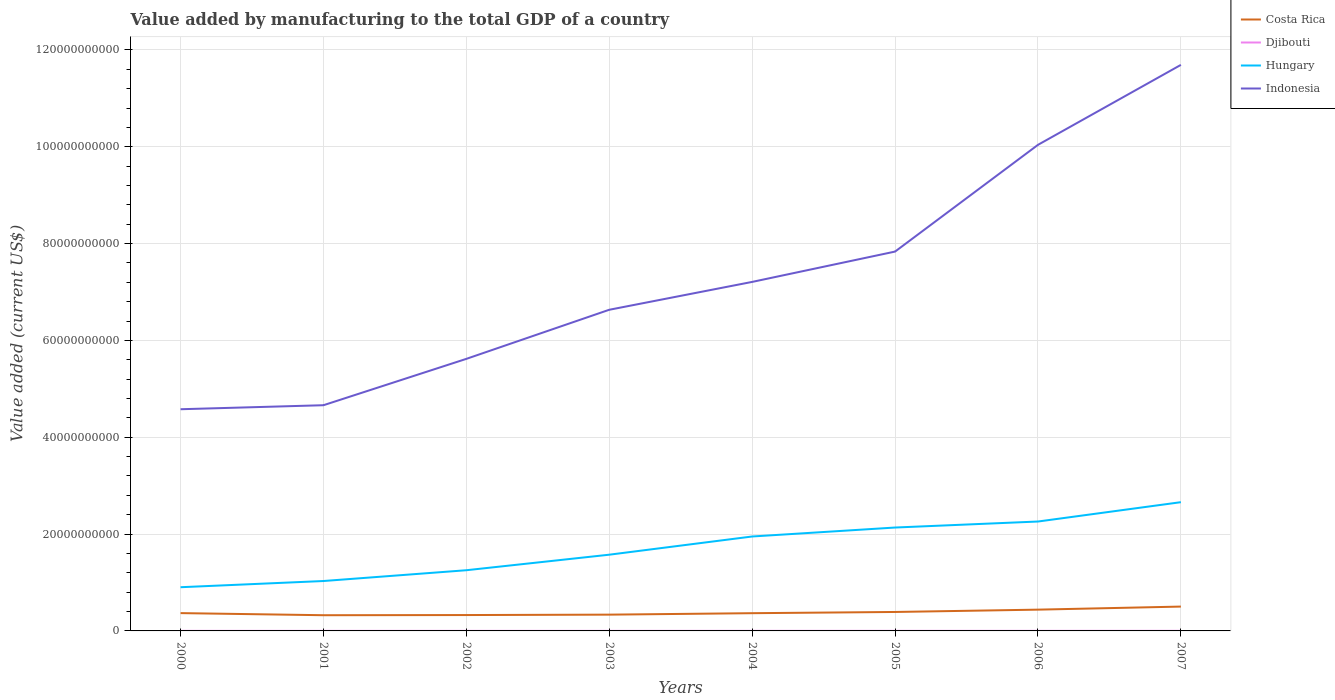Across all years, what is the maximum value added by manufacturing to the total GDP in Hungary?
Provide a succinct answer. 9.03e+09. In which year was the value added by manufacturing to the total GDP in Hungary maximum?
Provide a succinct answer. 2000. What is the total value added by manufacturing to the total GDP in Costa Rica in the graph?
Your answer should be very brief. -4.81e+08. What is the difference between the highest and the second highest value added by manufacturing to the total GDP in Djibouti?
Ensure brevity in your answer.  5.74e+06. What is the difference between the highest and the lowest value added by manufacturing to the total GDP in Hungary?
Offer a terse response. 4. Are the values on the major ticks of Y-axis written in scientific E-notation?
Ensure brevity in your answer.  No. How many legend labels are there?
Give a very brief answer. 4. What is the title of the graph?
Ensure brevity in your answer.  Value added by manufacturing to the total GDP of a country. Does "Botswana" appear as one of the legend labels in the graph?
Your answer should be very brief. No. What is the label or title of the X-axis?
Give a very brief answer. Years. What is the label or title of the Y-axis?
Keep it short and to the point. Value added (current US$). What is the Value added (current US$) of Costa Rica in 2000?
Provide a succinct answer. 3.68e+09. What is the Value added (current US$) of Djibouti in 2000?
Give a very brief answer. 1.26e+07. What is the Value added (current US$) in Hungary in 2000?
Offer a terse response. 9.03e+09. What is the Value added (current US$) of Indonesia in 2000?
Provide a short and direct response. 4.58e+1. What is the Value added (current US$) of Costa Rica in 2001?
Provide a short and direct response. 3.24e+09. What is the Value added (current US$) in Djibouti in 2001?
Offer a very short reply. 1.32e+07. What is the Value added (current US$) in Hungary in 2001?
Your answer should be compact. 1.03e+1. What is the Value added (current US$) in Indonesia in 2001?
Provide a succinct answer. 4.66e+1. What is the Value added (current US$) of Costa Rica in 2002?
Offer a very short reply. 3.28e+09. What is the Value added (current US$) in Djibouti in 2002?
Your answer should be compact. 1.37e+07. What is the Value added (current US$) in Hungary in 2002?
Provide a succinct answer. 1.25e+1. What is the Value added (current US$) of Indonesia in 2002?
Provide a succinct answer. 5.62e+1. What is the Value added (current US$) of Costa Rica in 2003?
Ensure brevity in your answer.  3.36e+09. What is the Value added (current US$) in Djibouti in 2003?
Keep it short and to the point. 1.44e+07. What is the Value added (current US$) of Hungary in 2003?
Offer a terse response. 1.57e+1. What is the Value added (current US$) in Indonesia in 2003?
Make the answer very short. 6.63e+1. What is the Value added (current US$) of Costa Rica in 2004?
Your answer should be very brief. 3.66e+09. What is the Value added (current US$) in Djibouti in 2004?
Offer a terse response. 1.54e+07. What is the Value added (current US$) of Hungary in 2004?
Offer a very short reply. 1.95e+1. What is the Value added (current US$) of Indonesia in 2004?
Offer a very short reply. 7.21e+1. What is the Value added (current US$) of Costa Rica in 2005?
Offer a terse response. 3.91e+09. What is the Value added (current US$) of Djibouti in 2005?
Provide a succinct answer. 1.63e+07. What is the Value added (current US$) of Hungary in 2005?
Make the answer very short. 2.14e+1. What is the Value added (current US$) of Indonesia in 2005?
Keep it short and to the point. 7.83e+1. What is the Value added (current US$) in Costa Rica in 2006?
Provide a succinct answer. 4.40e+09. What is the Value added (current US$) of Djibouti in 2006?
Give a very brief answer. 1.73e+07. What is the Value added (current US$) in Hungary in 2006?
Provide a succinct answer. 2.26e+1. What is the Value added (current US$) of Indonesia in 2006?
Keep it short and to the point. 1.00e+11. What is the Value added (current US$) of Costa Rica in 2007?
Keep it short and to the point. 5.03e+09. What is the Value added (current US$) of Djibouti in 2007?
Your answer should be compact. 1.83e+07. What is the Value added (current US$) of Hungary in 2007?
Provide a succinct answer. 2.66e+1. What is the Value added (current US$) in Indonesia in 2007?
Provide a short and direct response. 1.17e+11. Across all years, what is the maximum Value added (current US$) in Costa Rica?
Offer a terse response. 5.03e+09. Across all years, what is the maximum Value added (current US$) in Djibouti?
Keep it short and to the point. 1.83e+07. Across all years, what is the maximum Value added (current US$) of Hungary?
Your answer should be compact. 2.66e+1. Across all years, what is the maximum Value added (current US$) of Indonesia?
Provide a succinct answer. 1.17e+11. Across all years, what is the minimum Value added (current US$) in Costa Rica?
Your answer should be compact. 3.24e+09. Across all years, what is the minimum Value added (current US$) in Djibouti?
Offer a very short reply. 1.26e+07. Across all years, what is the minimum Value added (current US$) of Hungary?
Make the answer very short. 9.03e+09. Across all years, what is the minimum Value added (current US$) of Indonesia?
Give a very brief answer. 4.58e+1. What is the total Value added (current US$) in Costa Rica in the graph?
Keep it short and to the point. 3.06e+1. What is the total Value added (current US$) of Djibouti in the graph?
Provide a succinct answer. 1.21e+08. What is the total Value added (current US$) in Hungary in the graph?
Keep it short and to the point. 1.38e+11. What is the total Value added (current US$) in Indonesia in the graph?
Keep it short and to the point. 5.83e+11. What is the difference between the Value added (current US$) of Costa Rica in 2000 and that in 2001?
Make the answer very short. 4.34e+08. What is the difference between the Value added (current US$) in Djibouti in 2000 and that in 2001?
Provide a succinct answer. -6.18e+05. What is the difference between the Value added (current US$) in Hungary in 2000 and that in 2001?
Your response must be concise. -1.28e+09. What is the difference between the Value added (current US$) of Indonesia in 2000 and that in 2001?
Make the answer very short. -8.29e+08. What is the difference between the Value added (current US$) of Costa Rica in 2000 and that in 2002?
Your answer should be compact. 4.00e+08. What is the difference between the Value added (current US$) in Djibouti in 2000 and that in 2002?
Offer a terse response. -1.11e+06. What is the difference between the Value added (current US$) of Hungary in 2000 and that in 2002?
Ensure brevity in your answer.  -3.51e+09. What is the difference between the Value added (current US$) of Indonesia in 2000 and that in 2002?
Make the answer very short. -1.04e+1. What is the difference between the Value added (current US$) of Costa Rica in 2000 and that in 2003?
Offer a very short reply. 3.16e+08. What is the difference between the Value added (current US$) of Djibouti in 2000 and that in 2003?
Give a very brief answer. -1.81e+06. What is the difference between the Value added (current US$) of Hungary in 2000 and that in 2003?
Give a very brief answer. -6.72e+09. What is the difference between the Value added (current US$) in Indonesia in 2000 and that in 2003?
Ensure brevity in your answer.  -2.05e+1. What is the difference between the Value added (current US$) of Costa Rica in 2000 and that in 2004?
Provide a short and direct response. 1.61e+07. What is the difference between the Value added (current US$) of Djibouti in 2000 and that in 2004?
Your answer should be very brief. -2.86e+06. What is the difference between the Value added (current US$) of Hungary in 2000 and that in 2004?
Offer a terse response. -1.05e+1. What is the difference between the Value added (current US$) of Indonesia in 2000 and that in 2004?
Provide a short and direct response. -2.63e+1. What is the difference between the Value added (current US$) in Costa Rica in 2000 and that in 2005?
Make the answer very short. -2.38e+08. What is the difference between the Value added (current US$) in Djibouti in 2000 and that in 2005?
Offer a terse response. -3.74e+06. What is the difference between the Value added (current US$) of Hungary in 2000 and that in 2005?
Offer a terse response. -1.23e+1. What is the difference between the Value added (current US$) of Indonesia in 2000 and that in 2005?
Offer a terse response. -3.26e+1. What is the difference between the Value added (current US$) of Costa Rica in 2000 and that in 2006?
Provide a short and direct response. -7.19e+08. What is the difference between the Value added (current US$) in Djibouti in 2000 and that in 2006?
Provide a short and direct response. -4.69e+06. What is the difference between the Value added (current US$) of Hungary in 2000 and that in 2006?
Provide a short and direct response. -1.36e+1. What is the difference between the Value added (current US$) of Indonesia in 2000 and that in 2006?
Ensure brevity in your answer.  -5.46e+1. What is the difference between the Value added (current US$) in Costa Rica in 2000 and that in 2007?
Keep it short and to the point. -1.35e+09. What is the difference between the Value added (current US$) of Djibouti in 2000 and that in 2007?
Offer a very short reply. -5.74e+06. What is the difference between the Value added (current US$) of Hungary in 2000 and that in 2007?
Offer a terse response. -1.76e+1. What is the difference between the Value added (current US$) in Indonesia in 2000 and that in 2007?
Ensure brevity in your answer.  -7.11e+1. What is the difference between the Value added (current US$) of Costa Rica in 2001 and that in 2002?
Your answer should be very brief. -3.42e+07. What is the difference between the Value added (current US$) in Djibouti in 2001 and that in 2002?
Provide a succinct answer. -4.95e+05. What is the difference between the Value added (current US$) of Hungary in 2001 and that in 2002?
Give a very brief answer. -2.23e+09. What is the difference between the Value added (current US$) in Indonesia in 2001 and that in 2002?
Offer a very short reply. -9.58e+09. What is the difference between the Value added (current US$) of Costa Rica in 2001 and that in 2003?
Your answer should be compact. -1.18e+08. What is the difference between the Value added (current US$) of Djibouti in 2001 and that in 2003?
Provide a short and direct response. -1.20e+06. What is the difference between the Value added (current US$) of Hungary in 2001 and that in 2003?
Your response must be concise. -5.44e+09. What is the difference between the Value added (current US$) of Indonesia in 2001 and that in 2003?
Provide a succinct answer. -1.97e+1. What is the difference between the Value added (current US$) in Costa Rica in 2001 and that in 2004?
Keep it short and to the point. -4.18e+08. What is the difference between the Value added (current US$) of Djibouti in 2001 and that in 2004?
Provide a short and direct response. -2.24e+06. What is the difference between the Value added (current US$) in Hungary in 2001 and that in 2004?
Give a very brief answer. -9.20e+09. What is the difference between the Value added (current US$) of Indonesia in 2001 and that in 2004?
Provide a succinct answer. -2.55e+1. What is the difference between the Value added (current US$) in Costa Rica in 2001 and that in 2005?
Your answer should be compact. -6.72e+08. What is the difference between the Value added (current US$) of Djibouti in 2001 and that in 2005?
Provide a succinct answer. -3.12e+06. What is the difference between the Value added (current US$) of Hungary in 2001 and that in 2005?
Your answer should be very brief. -1.10e+1. What is the difference between the Value added (current US$) in Indonesia in 2001 and that in 2005?
Offer a very short reply. -3.17e+1. What is the difference between the Value added (current US$) in Costa Rica in 2001 and that in 2006?
Your response must be concise. -1.15e+09. What is the difference between the Value added (current US$) of Djibouti in 2001 and that in 2006?
Your answer should be very brief. -4.07e+06. What is the difference between the Value added (current US$) of Hungary in 2001 and that in 2006?
Your response must be concise. -1.23e+1. What is the difference between the Value added (current US$) of Indonesia in 2001 and that in 2006?
Provide a short and direct response. -5.38e+1. What is the difference between the Value added (current US$) in Costa Rica in 2001 and that in 2007?
Your answer should be very brief. -1.78e+09. What is the difference between the Value added (current US$) of Djibouti in 2001 and that in 2007?
Your answer should be very brief. -5.12e+06. What is the difference between the Value added (current US$) in Hungary in 2001 and that in 2007?
Offer a very short reply. -1.63e+1. What is the difference between the Value added (current US$) of Indonesia in 2001 and that in 2007?
Your answer should be compact. -7.03e+1. What is the difference between the Value added (current US$) of Costa Rica in 2002 and that in 2003?
Your answer should be compact. -8.42e+07. What is the difference between the Value added (current US$) of Djibouti in 2002 and that in 2003?
Provide a short and direct response. -7.02e+05. What is the difference between the Value added (current US$) of Hungary in 2002 and that in 2003?
Keep it short and to the point. -3.21e+09. What is the difference between the Value added (current US$) in Indonesia in 2002 and that in 2003?
Provide a short and direct response. -1.01e+1. What is the difference between the Value added (current US$) in Costa Rica in 2002 and that in 2004?
Provide a succinct answer. -3.84e+08. What is the difference between the Value added (current US$) in Djibouti in 2002 and that in 2004?
Your answer should be very brief. -1.75e+06. What is the difference between the Value added (current US$) in Hungary in 2002 and that in 2004?
Provide a succinct answer. -6.97e+09. What is the difference between the Value added (current US$) in Indonesia in 2002 and that in 2004?
Make the answer very short. -1.59e+1. What is the difference between the Value added (current US$) of Costa Rica in 2002 and that in 2005?
Offer a terse response. -6.38e+08. What is the difference between the Value added (current US$) of Djibouti in 2002 and that in 2005?
Keep it short and to the point. -2.62e+06. What is the difference between the Value added (current US$) of Hungary in 2002 and that in 2005?
Provide a succinct answer. -8.82e+09. What is the difference between the Value added (current US$) in Indonesia in 2002 and that in 2005?
Your answer should be compact. -2.22e+1. What is the difference between the Value added (current US$) in Costa Rica in 2002 and that in 2006?
Ensure brevity in your answer.  -1.12e+09. What is the difference between the Value added (current US$) in Djibouti in 2002 and that in 2006?
Offer a terse response. -3.58e+06. What is the difference between the Value added (current US$) in Hungary in 2002 and that in 2006?
Your answer should be very brief. -1.01e+1. What is the difference between the Value added (current US$) of Indonesia in 2002 and that in 2006?
Your answer should be very brief. -4.42e+1. What is the difference between the Value added (current US$) in Costa Rica in 2002 and that in 2007?
Your answer should be compact. -1.75e+09. What is the difference between the Value added (current US$) in Djibouti in 2002 and that in 2007?
Keep it short and to the point. -4.63e+06. What is the difference between the Value added (current US$) of Hungary in 2002 and that in 2007?
Make the answer very short. -1.41e+1. What is the difference between the Value added (current US$) in Indonesia in 2002 and that in 2007?
Keep it short and to the point. -6.07e+1. What is the difference between the Value added (current US$) of Costa Rica in 2003 and that in 2004?
Your answer should be compact. -3.00e+08. What is the difference between the Value added (current US$) of Djibouti in 2003 and that in 2004?
Offer a very short reply. -1.04e+06. What is the difference between the Value added (current US$) of Hungary in 2003 and that in 2004?
Provide a succinct answer. -3.76e+09. What is the difference between the Value added (current US$) of Indonesia in 2003 and that in 2004?
Your answer should be very brief. -5.75e+09. What is the difference between the Value added (current US$) in Costa Rica in 2003 and that in 2005?
Provide a succinct answer. -5.53e+08. What is the difference between the Value added (current US$) of Djibouti in 2003 and that in 2005?
Your answer should be very brief. -1.92e+06. What is the difference between the Value added (current US$) in Hungary in 2003 and that in 2005?
Provide a succinct answer. -5.61e+09. What is the difference between the Value added (current US$) of Indonesia in 2003 and that in 2005?
Ensure brevity in your answer.  -1.20e+1. What is the difference between the Value added (current US$) in Costa Rica in 2003 and that in 2006?
Provide a succinct answer. -1.03e+09. What is the difference between the Value added (current US$) in Djibouti in 2003 and that in 2006?
Your answer should be compact. -2.87e+06. What is the difference between the Value added (current US$) of Hungary in 2003 and that in 2006?
Provide a short and direct response. -6.85e+09. What is the difference between the Value added (current US$) of Indonesia in 2003 and that in 2006?
Make the answer very short. -3.41e+1. What is the difference between the Value added (current US$) of Costa Rica in 2003 and that in 2007?
Provide a short and direct response. -1.67e+09. What is the difference between the Value added (current US$) of Djibouti in 2003 and that in 2007?
Offer a terse response. -3.93e+06. What is the difference between the Value added (current US$) of Hungary in 2003 and that in 2007?
Your response must be concise. -1.08e+1. What is the difference between the Value added (current US$) in Indonesia in 2003 and that in 2007?
Provide a succinct answer. -5.06e+1. What is the difference between the Value added (current US$) in Costa Rica in 2004 and that in 2005?
Provide a short and direct response. -2.54e+08. What is the difference between the Value added (current US$) of Djibouti in 2004 and that in 2005?
Offer a very short reply. -8.77e+05. What is the difference between the Value added (current US$) in Hungary in 2004 and that in 2005?
Offer a very short reply. -1.85e+09. What is the difference between the Value added (current US$) of Indonesia in 2004 and that in 2005?
Your answer should be very brief. -6.27e+09. What is the difference between the Value added (current US$) of Costa Rica in 2004 and that in 2006?
Give a very brief answer. -7.35e+08. What is the difference between the Value added (current US$) of Djibouti in 2004 and that in 2006?
Provide a short and direct response. -1.83e+06. What is the difference between the Value added (current US$) in Hungary in 2004 and that in 2006?
Offer a very short reply. -3.09e+09. What is the difference between the Value added (current US$) of Indonesia in 2004 and that in 2006?
Provide a succinct answer. -2.83e+1. What is the difference between the Value added (current US$) of Costa Rica in 2004 and that in 2007?
Your answer should be compact. -1.37e+09. What is the difference between the Value added (current US$) of Djibouti in 2004 and that in 2007?
Give a very brief answer. -2.88e+06. What is the difference between the Value added (current US$) in Hungary in 2004 and that in 2007?
Offer a terse response. -7.09e+09. What is the difference between the Value added (current US$) of Indonesia in 2004 and that in 2007?
Make the answer very short. -4.48e+1. What is the difference between the Value added (current US$) in Costa Rica in 2005 and that in 2006?
Make the answer very short. -4.81e+08. What is the difference between the Value added (current US$) of Djibouti in 2005 and that in 2006?
Your answer should be very brief. -9.53e+05. What is the difference between the Value added (current US$) in Hungary in 2005 and that in 2006?
Offer a very short reply. -1.24e+09. What is the difference between the Value added (current US$) in Indonesia in 2005 and that in 2006?
Make the answer very short. -2.20e+1. What is the difference between the Value added (current US$) in Costa Rica in 2005 and that in 2007?
Make the answer very short. -1.11e+09. What is the difference between the Value added (current US$) in Djibouti in 2005 and that in 2007?
Ensure brevity in your answer.  -2.00e+06. What is the difference between the Value added (current US$) in Hungary in 2005 and that in 2007?
Give a very brief answer. -5.24e+09. What is the difference between the Value added (current US$) in Indonesia in 2005 and that in 2007?
Make the answer very short. -3.86e+1. What is the difference between the Value added (current US$) of Costa Rica in 2006 and that in 2007?
Provide a succinct answer. -6.32e+08. What is the difference between the Value added (current US$) of Djibouti in 2006 and that in 2007?
Offer a terse response. -1.05e+06. What is the difference between the Value added (current US$) in Hungary in 2006 and that in 2007?
Offer a very short reply. -3.99e+09. What is the difference between the Value added (current US$) in Indonesia in 2006 and that in 2007?
Provide a short and direct response. -1.65e+1. What is the difference between the Value added (current US$) of Costa Rica in 2000 and the Value added (current US$) of Djibouti in 2001?
Offer a terse response. 3.66e+09. What is the difference between the Value added (current US$) in Costa Rica in 2000 and the Value added (current US$) in Hungary in 2001?
Offer a terse response. -6.63e+09. What is the difference between the Value added (current US$) of Costa Rica in 2000 and the Value added (current US$) of Indonesia in 2001?
Your answer should be very brief. -4.29e+1. What is the difference between the Value added (current US$) of Djibouti in 2000 and the Value added (current US$) of Hungary in 2001?
Your answer should be compact. -1.03e+1. What is the difference between the Value added (current US$) of Djibouti in 2000 and the Value added (current US$) of Indonesia in 2001?
Make the answer very short. -4.66e+1. What is the difference between the Value added (current US$) in Hungary in 2000 and the Value added (current US$) in Indonesia in 2001?
Give a very brief answer. -3.76e+1. What is the difference between the Value added (current US$) of Costa Rica in 2000 and the Value added (current US$) of Djibouti in 2002?
Offer a terse response. 3.66e+09. What is the difference between the Value added (current US$) in Costa Rica in 2000 and the Value added (current US$) in Hungary in 2002?
Give a very brief answer. -8.86e+09. What is the difference between the Value added (current US$) of Costa Rica in 2000 and the Value added (current US$) of Indonesia in 2002?
Your response must be concise. -5.25e+1. What is the difference between the Value added (current US$) in Djibouti in 2000 and the Value added (current US$) in Hungary in 2002?
Provide a short and direct response. -1.25e+1. What is the difference between the Value added (current US$) of Djibouti in 2000 and the Value added (current US$) of Indonesia in 2002?
Keep it short and to the point. -5.62e+1. What is the difference between the Value added (current US$) in Hungary in 2000 and the Value added (current US$) in Indonesia in 2002?
Make the answer very short. -4.72e+1. What is the difference between the Value added (current US$) of Costa Rica in 2000 and the Value added (current US$) of Djibouti in 2003?
Your answer should be compact. 3.66e+09. What is the difference between the Value added (current US$) in Costa Rica in 2000 and the Value added (current US$) in Hungary in 2003?
Your answer should be compact. -1.21e+1. What is the difference between the Value added (current US$) in Costa Rica in 2000 and the Value added (current US$) in Indonesia in 2003?
Keep it short and to the point. -6.27e+1. What is the difference between the Value added (current US$) of Djibouti in 2000 and the Value added (current US$) of Hungary in 2003?
Your response must be concise. -1.57e+1. What is the difference between the Value added (current US$) of Djibouti in 2000 and the Value added (current US$) of Indonesia in 2003?
Offer a very short reply. -6.63e+1. What is the difference between the Value added (current US$) in Hungary in 2000 and the Value added (current US$) in Indonesia in 2003?
Provide a succinct answer. -5.73e+1. What is the difference between the Value added (current US$) of Costa Rica in 2000 and the Value added (current US$) of Djibouti in 2004?
Offer a terse response. 3.66e+09. What is the difference between the Value added (current US$) of Costa Rica in 2000 and the Value added (current US$) of Hungary in 2004?
Your answer should be very brief. -1.58e+1. What is the difference between the Value added (current US$) in Costa Rica in 2000 and the Value added (current US$) in Indonesia in 2004?
Offer a very short reply. -6.84e+1. What is the difference between the Value added (current US$) of Djibouti in 2000 and the Value added (current US$) of Hungary in 2004?
Ensure brevity in your answer.  -1.95e+1. What is the difference between the Value added (current US$) of Djibouti in 2000 and the Value added (current US$) of Indonesia in 2004?
Make the answer very short. -7.21e+1. What is the difference between the Value added (current US$) in Hungary in 2000 and the Value added (current US$) in Indonesia in 2004?
Your answer should be compact. -6.31e+1. What is the difference between the Value added (current US$) of Costa Rica in 2000 and the Value added (current US$) of Djibouti in 2005?
Make the answer very short. 3.66e+09. What is the difference between the Value added (current US$) in Costa Rica in 2000 and the Value added (current US$) in Hungary in 2005?
Keep it short and to the point. -1.77e+1. What is the difference between the Value added (current US$) in Costa Rica in 2000 and the Value added (current US$) in Indonesia in 2005?
Offer a very short reply. -7.47e+1. What is the difference between the Value added (current US$) in Djibouti in 2000 and the Value added (current US$) in Hungary in 2005?
Keep it short and to the point. -2.13e+1. What is the difference between the Value added (current US$) in Djibouti in 2000 and the Value added (current US$) in Indonesia in 2005?
Offer a terse response. -7.83e+1. What is the difference between the Value added (current US$) of Hungary in 2000 and the Value added (current US$) of Indonesia in 2005?
Keep it short and to the point. -6.93e+1. What is the difference between the Value added (current US$) in Costa Rica in 2000 and the Value added (current US$) in Djibouti in 2006?
Provide a short and direct response. 3.66e+09. What is the difference between the Value added (current US$) of Costa Rica in 2000 and the Value added (current US$) of Hungary in 2006?
Ensure brevity in your answer.  -1.89e+1. What is the difference between the Value added (current US$) in Costa Rica in 2000 and the Value added (current US$) in Indonesia in 2006?
Offer a very short reply. -9.67e+1. What is the difference between the Value added (current US$) of Djibouti in 2000 and the Value added (current US$) of Hungary in 2006?
Provide a succinct answer. -2.26e+1. What is the difference between the Value added (current US$) of Djibouti in 2000 and the Value added (current US$) of Indonesia in 2006?
Your answer should be compact. -1.00e+11. What is the difference between the Value added (current US$) of Hungary in 2000 and the Value added (current US$) of Indonesia in 2006?
Your answer should be compact. -9.14e+1. What is the difference between the Value added (current US$) in Costa Rica in 2000 and the Value added (current US$) in Djibouti in 2007?
Provide a succinct answer. 3.66e+09. What is the difference between the Value added (current US$) of Costa Rica in 2000 and the Value added (current US$) of Hungary in 2007?
Keep it short and to the point. -2.29e+1. What is the difference between the Value added (current US$) in Costa Rica in 2000 and the Value added (current US$) in Indonesia in 2007?
Make the answer very short. -1.13e+11. What is the difference between the Value added (current US$) in Djibouti in 2000 and the Value added (current US$) in Hungary in 2007?
Make the answer very short. -2.66e+1. What is the difference between the Value added (current US$) in Djibouti in 2000 and the Value added (current US$) in Indonesia in 2007?
Your answer should be very brief. -1.17e+11. What is the difference between the Value added (current US$) in Hungary in 2000 and the Value added (current US$) in Indonesia in 2007?
Keep it short and to the point. -1.08e+11. What is the difference between the Value added (current US$) in Costa Rica in 2001 and the Value added (current US$) in Djibouti in 2002?
Your response must be concise. 3.23e+09. What is the difference between the Value added (current US$) in Costa Rica in 2001 and the Value added (current US$) in Hungary in 2002?
Give a very brief answer. -9.29e+09. What is the difference between the Value added (current US$) in Costa Rica in 2001 and the Value added (current US$) in Indonesia in 2002?
Your answer should be very brief. -5.29e+1. What is the difference between the Value added (current US$) in Djibouti in 2001 and the Value added (current US$) in Hungary in 2002?
Provide a succinct answer. -1.25e+1. What is the difference between the Value added (current US$) in Djibouti in 2001 and the Value added (current US$) in Indonesia in 2002?
Provide a succinct answer. -5.62e+1. What is the difference between the Value added (current US$) in Hungary in 2001 and the Value added (current US$) in Indonesia in 2002?
Your answer should be very brief. -4.59e+1. What is the difference between the Value added (current US$) in Costa Rica in 2001 and the Value added (current US$) in Djibouti in 2003?
Offer a very short reply. 3.23e+09. What is the difference between the Value added (current US$) of Costa Rica in 2001 and the Value added (current US$) of Hungary in 2003?
Offer a very short reply. -1.25e+1. What is the difference between the Value added (current US$) in Costa Rica in 2001 and the Value added (current US$) in Indonesia in 2003?
Give a very brief answer. -6.31e+1. What is the difference between the Value added (current US$) in Djibouti in 2001 and the Value added (current US$) in Hungary in 2003?
Keep it short and to the point. -1.57e+1. What is the difference between the Value added (current US$) of Djibouti in 2001 and the Value added (current US$) of Indonesia in 2003?
Give a very brief answer. -6.63e+1. What is the difference between the Value added (current US$) of Hungary in 2001 and the Value added (current US$) of Indonesia in 2003?
Keep it short and to the point. -5.60e+1. What is the difference between the Value added (current US$) of Costa Rica in 2001 and the Value added (current US$) of Djibouti in 2004?
Your response must be concise. 3.23e+09. What is the difference between the Value added (current US$) of Costa Rica in 2001 and the Value added (current US$) of Hungary in 2004?
Ensure brevity in your answer.  -1.63e+1. What is the difference between the Value added (current US$) of Costa Rica in 2001 and the Value added (current US$) of Indonesia in 2004?
Make the answer very short. -6.88e+1. What is the difference between the Value added (current US$) in Djibouti in 2001 and the Value added (current US$) in Hungary in 2004?
Provide a short and direct response. -1.95e+1. What is the difference between the Value added (current US$) in Djibouti in 2001 and the Value added (current US$) in Indonesia in 2004?
Offer a very short reply. -7.21e+1. What is the difference between the Value added (current US$) of Hungary in 2001 and the Value added (current US$) of Indonesia in 2004?
Your response must be concise. -6.18e+1. What is the difference between the Value added (current US$) of Costa Rica in 2001 and the Value added (current US$) of Djibouti in 2005?
Keep it short and to the point. 3.23e+09. What is the difference between the Value added (current US$) of Costa Rica in 2001 and the Value added (current US$) of Hungary in 2005?
Provide a succinct answer. -1.81e+1. What is the difference between the Value added (current US$) of Costa Rica in 2001 and the Value added (current US$) of Indonesia in 2005?
Give a very brief answer. -7.51e+1. What is the difference between the Value added (current US$) of Djibouti in 2001 and the Value added (current US$) of Hungary in 2005?
Offer a terse response. -2.13e+1. What is the difference between the Value added (current US$) in Djibouti in 2001 and the Value added (current US$) in Indonesia in 2005?
Your answer should be very brief. -7.83e+1. What is the difference between the Value added (current US$) in Hungary in 2001 and the Value added (current US$) in Indonesia in 2005?
Provide a short and direct response. -6.80e+1. What is the difference between the Value added (current US$) of Costa Rica in 2001 and the Value added (current US$) of Djibouti in 2006?
Make the answer very short. 3.23e+09. What is the difference between the Value added (current US$) in Costa Rica in 2001 and the Value added (current US$) in Hungary in 2006?
Offer a terse response. -1.94e+1. What is the difference between the Value added (current US$) in Costa Rica in 2001 and the Value added (current US$) in Indonesia in 2006?
Offer a very short reply. -9.72e+1. What is the difference between the Value added (current US$) of Djibouti in 2001 and the Value added (current US$) of Hungary in 2006?
Your answer should be very brief. -2.26e+1. What is the difference between the Value added (current US$) in Djibouti in 2001 and the Value added (current US$) in Indonesia in 2006?
Your answer should be compact. -1.00e+11. What is the difference between the Value added (current US$) in Hungary in 2001 and the Value added (current US$) in Indonesia in 2006?
Provide a short and direct response. -9.01e+1. What is the difference between the Value added (current US$) of Costa Rica in 2001 and the Value added (current US$) of Djibouti in 2007?
Make the answer very short. 3.22e+09. What is the difference between the Value added (current US$) of Costa Rica in 2001 and the Value added (current US$) of Hungary in 2007?
Your answer should be very brief. -2.33e+1. What is the difference between the Value added (current US$) of Costa Rica in 2001 and the Value added (current US$) of Indonesia in 2007?
Your response must be concise. -1.14e+11. What is the difference between the Value added (current US$) in Djibouti in 2001 and the Value added (current US$) in Hungary in 2007?
Make the answer very short. -2.66e+1. What is the difference between the Value added (current US$) in Djibouti in 2001 and the Value added (current US$) in Indonesia in 2007?
Provide a succinct answer. -1.17e+11. What is the difference between the Value added (current US$) in Hungary in 2001 and the Value added (current US$) in Indonesia in 2007?
Your answer should be compact. -1.07e+11. What is the difference between the Value added (current US$) in Costa Rica in 2002 and the Value added (current US$) in Djibouti in 2003?
Ensure brevity in your answer.  3.26e+09. What is the difference between the Value added (current US$) in Costa Rica in 2002 and the Value added (current US$) in Hungary in 2003?
Offer a very short reply. -1.25e+1. What is the difference between the Value added (current US$) of Costa Rica in 2002 and the Value added (current US$) of Indonesia in 2003?
Provide a succinct answer. -6.31e+1. What is the difference between the Value added (current US$) of Djibouti in 2002 and the Value added (current US$) of Hungary in 2003?
Your response must be concise. -1.57e+1. What is the difference between the Value added (current US$) in Djibouti in 2002 and the Value added (current US$) in Indonesia in 2003?
Your response must be concise. -6.63e+1. What is the difference between the Value added (current US$) of Hungary in 2002 and the Value added (current US$) of Indonesia in 2003?
Ensure brevity in your answer.  -5.38e+1. What is the difference between the Value added (current US$) in Costa Rica in 2002 and the Value added (current US$) in Djibouti in 2004?
Your response must be concise. 3.26e+09. What is the difference between the Value added (current US$) of Costa Rica in 2002 and the Value added (current US$) of Hungary in 2004?
Offer a very short reply. -1.62e+1. What is the difference between the Value added (current US$) of Costa Rica in 2002 and the Value added (current US$) of Indonesia in 2004?
Ensure brevity in your answer.  -6.88e+1. What is the difference between the Value added (current US$) in Djibouti in 2002 and the Value added (current US$) in Hungary in 2004?
Keep it short and to the point. -1.95e+1. What is the difference between the Value added (current US$) in Djibouti in 2002 and the Value added (current US$) in Indonesia in 2004?
Your answer should be very brief. -7.21e+1. What is the difference between the Value added (current US$) of Hungary in 2002 and the Value added (current US$) of Indonesia in 2004?
Make the answer very short. -5.95e+1. What is the difference between the Value added (current US$) of Costa Rica in 2002 and the Value added (current US$) of Djibouti in 2005?
Ensure brevity in your answer.  3.26e+09. What is the difference between the Value added (current US$) in Costa Rica in 2002 and the Value added (current US$) in Hungary in 2005?
Provide a short and direct response. -1.81e+1. What is the difference between the Value added (current US$) of Costa Rica in 2002 and the Value added (current US$) of Indonesia in 2005?
Your response must be concise. -7.51e+1. What is the difference between the Value added (current US$) of Djibouti in 2002 and the Value added (current US$) of Hungary in 2005?
Your answer should be compact. -2.13e+1. What is the difference between the Value added (current US$) in Djibouti in 2002 and the Value added (current US$) in Indonesia in 2005?
Make the answer very short. -7.83e+1. What is the difference between the Value added (current US$) of Hungary in 2002 and the Value added (current US$) of Indonesia in 2005?
Offer a very short reply. -6.58e+1. What is the difference between the Value added (current US$) of Costa Rica in 2002 and the Value added (current US$) of Djibouti in 2006?
Give a very brief answer. 3.26e+09. What is the difference between the Value added (current US$) of Costa Rica in 2002 and the Value added (current US$) of Hungary in 2006?
Make the answer very short. -1.93e+1. What is the difference between the Value added (current US$) of Costa Rica in 2002 and the Value added (current US$) of Indonesia in 2006?
Offer a terse response. -9.71e+1. What is the difference between the Value added (current US$) in Djibouti in 2002 and the Value added (current US$) in Hungary in 2006?
Give a very brief answer. -2.26e+1. What is the difference between the Value added (current US$) in Djibouti in 2002 and the Value added (current US$) in Indonesia in 2006?
Your answer should be very brief. -1.00e+11. What is the difference between the Value added (current US$) of Hungary in 2002 and the Value added (current US$) of Indonesia in 2006?
Your response must be concise. -8.79e+1. What is the difference between the Value added (current US$) in Costa Rica in 2002 and the Value added (current US$) in Djibouti in 2007?
Your answer should be very brief. 3.26e+09. What is the difference between the Value added (current US$) of Costa Rica in 2002 and the Value added (current US$) of Hungary in 2007?
Keep it short and to the point. -2.33e+1. What is the difference between the Value added (current US$) in Costa Rica in 2002 and the Value added (current US$) in Indonesia in 2007?
Make the answer very short. -1.14e+11. What is the difference between the Value added (current US$) of Djibouti in 2002 and the Value added (current US$) of Hungary in 2007?
Provide a succinct answer. -2.66e+1. What is the difference between the Value added (current US$) in Djibouti in 2002 and the Value added (current US$) in Indonesia in 2007?
Keep it short and to the point. -1.17e+11. What is the difference between the Value added (current US$) of Hungary in 2002 and the Value added (current US$) of Indonesia in 2007?
Provide a succinct answer. -1.04e+11. What is the difference between the Value added (current US$) of Costa Rica in 2003 and the Value added (current US$) of Djibouti in 2004?
Your response must be concise. 3.35e+09. What is the difference between the Value added (current US$) in Costa Rica in 2003 and the Value added (current US$) in Hungary in 2004?
Your answer should be very brief. -1.61e+1. What is the difference between the Value added (current US$) in Costa Rica in 2003 and the Value added (current US$) in Indonesia in 2004?
Your answer should be very brief. -6.87e+1. What is the difference between the Value added (current US$) of Djibouti in 2003 and the Value added (current US$) of Hungary in 2004?
Ensure brevity in your answer.  -1.95e+1. What is the difference between the Value added (current US$) in Djibouti in 2003 and the Value added (current US$) in Indonesia in 2004?
Offer a very short reply. -7.21e+1. What is the difference between the Value added (current US$) of Hungary in 2003 and the Value added (current US$) of Indonesia in 2004?
Give a very brief answer. -5.63e+1. What is the difference between the Value added (current US$) in Costa Rica in 2003 and the Value added (current US$) in Djibouti in 2005?
Provide a short and direct response. 3.35e+09. What is the difference between the Value added (current US$) in Costa Rica in 2003 and the Value added (current US$) in Hungary in 2005?
Keep it short and to the point. -1.80e+1. What is the difference between the Value added (current US$) in Costa Rica in 2003 and the Value added (current US$) in Indonesia in 2005?
Make the answer very short. -7.50e+1. What is the difference between the Value added (current US$) of Djibouti in 2003 and the Value added (current US$) of Hungary in 2005?
Keep it short and to the point. -2.13e+1. What is the difference between the Value added (current US$) of Djibouti in 2003 and the Value added (current US$) of Indonesia in 2005?
Make the answer very short. -7.83e+1. What is the difference between the Value added (current US$) of Hungary in 2003 and the Value added (current US$) of Indonesia in 2005?
Your answer should be very brief. -6.26e+1. What is the difference between the Value added (current US$) of Costa Rica in 2003 and the Value added (current US$) of Djibouti in 2006?
Offer a terse response. 3.34e+09. What is the difference between the Value added (current US$) of Costa Rica in 2003 and the Value added (current US$) of Hungary in 2006?
Provide a short and direct response. -1.92e+1. What is the difference between the Value added (current US$) in Costa Rica in 2003 and the Value added (current US$) in Indonesia in 2006?
Your answer should be very brief. -9.70e+1. What is the difference between the Value added (current US$) in Djibouti in 2003 and the Value added (current US$) in Hungary in 2006?
Your response must be concise. -2.26e+1. What is the difference between the Value added (current US$) of Djibouti in 2003 and the Value added (current US$) of Indonesia in 2006?
Offer a very short reply. -1.00e+11. What is the difference between the Value added (current US$) of Hungary in 2003 and the Value added (current US$) of Indonesia in 2006?
Provide a short and direct response. -8.47e+1. What is the difference between the Value added (current US$) in Costa Rica in 2003 and the Value added (current US$) in Djibouti in 2007?
Your response must be concise. 3.34e+09. What is the difference between the Value added (current US$) of Costa Rica in 2003 and the Value added (current US$) of Hungary in 2007?
Your response must be concise. -2.32e+1. What is the difference between the Value added (current US$) of Costa Rica in 2003 and the Value added (current US$) of Indonesia in 2007?
Offer a terse response. -1.14e+11. What is the difference between the Value added (current US$) in Djibouti in 2003 and the Value added (current US$) in Hungary in 2007?
Provide a succinct answer. -2.66e+1. What is the difference between the Value added (current US$) of Djibouti in 2003 and the Value added (current US$) of Indonesia in 2007?
Your answer should be very brief. -1.17e+11. What is the difference between the Value added (current US$) of Hungary in 2003 and the Value added (current US$) of Indonesia in 2007?
Keep it short and to the point. -1.01e+11. What is the difference between the Value added (current US$) in Costa Rica in 2004 and the Value added (current US$) in Djibouti in 2005?
Your answer should be compact. 3.64e+09. What is the difference between the Value added (current US$) in Costa Rica in 2004 and the Value added (current US$) in Hungary in 2005?
Your response must be concise. -1.77e+1. What is the difference between the Value added (current US$) in Costa Rica in 2004 and the Value added (current US$) in Indonesia in 2005?
Offer a very short reply. -7.47e+1. What is the difference between the Value added (current US$) in Djibouti in 2004 and the Value added (current US$) in Hungary in 2005?
Your answer should be compact. -2.13e+1. What is the difference between the Value added (current US$) of Djibouti in 2004 and the Value added (current US$) of Indonesia in 2005?
Give a very brief answer. -7.83e+1. What is the difference between the Value added (current US$) of Hungary in 2004 and the Value added (current US$) of Indonesia in 2005?
Offer a terse response. -5.88e+1. What is the difference between the Value added (current US$) in Costa Rica in 2004 and the Value added (current US$) in Djibouti in 2006?
Offer a very short reply. 3.64e+09. What is the difference between the Value added (current US$) of Costa Rica in 2004 and the Value added (current US$) of Hungary in 2006?
Offer a very short reply. -1.89e+1. What is the difference between the Value added (current US$) of Costa Rica in 2004 and the Value added (current US$) of Indonesia in 2006?
Your answer should be very brief. -9.67e+1. What is the difference between the Value added (current US$) in Djibouti in 2004 and the Value added (current US$) in Hungary in 2006?
Your response must be concise. -2.26e+1. What is the difference between the Value added (current US$) of Djibouti in 2004 and the Value added (current US$) of Indonesia in 2006?
Your answer should be very brief. -1.00e+11. What is the difference between the Value added (current US$) in Hungary in 2004 and the Value added (current US$) in Indonesia in 2006?
Provide a short and direct response. -8.09e+1. What is the difference between the Value added (current US$) of Costa Rica in 2004 and the Value added (current US$) of Djibouti in 2007?
Ensure brevity in your answer.  3.64e+09. What is the difference between the Value added (current US$) of Costa Rica in 2004 and the Value added (current US$) of Hungary in 2007?
Give a very brief answer. -2.29e+1. What is the difference between the Value added (current US$) of Costa Rica in 2004 and the Value added (current US$) of Indonesia in 2007?
Give a very brief answer. -1.13e+11. What is the difference between the Value added (current US$) of Djibouti in 2004 and the Value added (current US$) of Hungary in 2007?
Keep it short and to the point. -2.66e+1. What is the difference between the Value added (current US$) of Djibouti in 2004 and the Value added (current US$) of Indonesia in 2007?
Your answer should be very brief. -1.17e+11. What is the difference between the Value added (current US$) in Hungary in 2004 and the Value added (current US$) in Indonesia in 2007?
Your answer should be compact. -9.74e+1. What is the difference between the Value added (current US$) in Costa Rica in 2005 and the Value added (current US$) in Djibouti in 2006?
Your response must be concise. 3.90e+09. What is the difference between the Value added (current US$) of Costa Rica in 2005 and the Value added (current US$) of Hungary in 2006?
Your response must be concise. -1.87e+1. What is the difference between the Value added (current US$) in Costa Rica in 2005 and the Value added (current US$) in Indonesia in 2006?
Your answer should be compact. -9.65e+1. What is the difference between the Value added (current US$) of Djibouti in 2005 and the Value added (current US$) of Hungary in 2006?
Offer a terse response. -2.26e+1. What is the difference between the Value added (current US$) of Djibouti in 2005 and the Value added (current US$) of Indonesia in 2006?
Give a very brief answer. -1.00e+11. What is the difference between the Value added (current US$) in Hungary in 2005 and the Value added (current US$) in Indonesia in 2006?
Offer a terse response. -7.90e+1. What is the difference between the Value added (current US$) in Costa Rica in 2005 and the Value added (current US$) in Djibouti in 2007?
Your answer should be compact. 3.90e+09. What is the difference between the Value added (current US$) of Costa Rica in 2005 and the Value added (current US$) of Hungary in 2007?
Give a very brief answer. -2.27e+1. What is the difference between the Value added (current US$) of Costa Rica in 2005 and the Value added (current US$) of Indonesia in 2007?
Offer a terse response. -1.13e+11. What is the difference between the Value added (current US$) in Djibouti in 2005 and the Value added (current US$) in Hungary in 2007?
Keep it short and to the point. -2.66e+1. What is the difference between the Value added (current US$) of Djibouti in 2005 and the Value added (current US$) of Indonesia in 2007?
Offer a very short reply. -1.17e+11. What is the difference between the Value added (current US$) of Hungary in 2005 and the Value added (current US$) of Indonesia in 2007?
Make the answer very short. -9.56e+1. What is the difference between the Value added (current US$) of Costa Rica in 2006 and the Value added (current US$) of Djibouti in 2007?
Your response must be concise. 4.38e+09. What is the difference between the Value added (current US$) of Costa Rica in 2006 and the Value added (current US$) of Hungary in 2007?
Provide a succinct answer. -2.22e+1. What is the difference between the Value added (current US$) in Costa Rica in 2006 and the Value added (current US$) in Indonesia in 2007?
Provide a succinct answer. -1.13e+11. What is the difference between the Value added (current US$) of Djibouti in 2006 and the Value added (current US$) of Hungary in 2007?
Provide a short and direct response. -2.66e+1. What is the difference between the Value added (current US$) of Djibouti in 2006 and the Value added (current US$) of Indonesia in 2007?
Offer a very short reply. -1.17e+11. What is the difference between the Value added (current US$) of Hungary in 2006 and the Value added (current US$) of Indonesia in 2007?
Your answer should be very brief. -9.43e+1. What is the average Value added (current US$) of Costa Rica per year?
Provide a short and direct response. 3.82e+09. What is the average Value added (current US$) of Djibouti per year?
Provide a succinct answer. 1.51e+07. What is the average Value added (current US$) in Hungary per year?
Offer a terse response. 1.72e+1. What is the average Value added (current US$) of Indonesia per year?
Offer a very short reply. 7.28e+1. In the year 2000, what is the difference between the Value added (current US$) of Costa Rica and Value added (current US$) of Djibouti?
Keep it short and to the point. 3.66e+09. In the year 2000, what is the difference between the Value added (current US$) of Costa Rica and Value added (current US$) of Hungary?
Your answer should be compact. -5.35e+09. In the year 2000, what is the difference between the Value added (current US$) of Costa Rica and Value added (current US$) of Indonesia?
Provide a short and direct response. -4.21e+1. In the year 2000, what is the difference between the Value added (current US$) of Djibouti and Value added (current US$) of Hungary?
Your answer should be very brief. -9.01e+09. In the year 2000, what is the difference between the Value added (current US$) of Djibouti and Value added (current US$) of Indonesia?
Provide a short and direct response. -4.58e+1. In the year 2000, what is the difference between the Value added (current US$) of Hungary and Value added (current US$) of Indonesia?
Provide a succinct answer. -3.68e+1. In the year 2001, what is the difference between the Value added (current US$) in Costa Rica and Value added (current US$) in Djibouti?
Keep it short and to the point. 3.23e+09. In the year 2001, what is the difference between the Value added (current US$) of Costa Rica and Value added (current US$) of Hungary?
Give a very brief answer. -7.06e+09. In the year 2001, what is the difference between the Value added (current US$) in Costa Rica and Value added (current US$) in Indonesia?
Ensure brevity in your answer.  -4.34e+1. In the year 2001, what is the difference between the Value added (current US$) of Djibouti and Value added (current US$) of Hungary?
Your answer should be very brief. -1.03e+1. In the year 2001, what is the difference between the Value added (current US$) of Djibouti and Value added (current US$) of Indonesia?
Provide a succinct answer. -4.66e+1. In the year 2001, what is the difference between the Value added (current US$) of Hungary and Value added (current US$) of Indonesia?
Offer a very short reply. -3.63e+1. In the year 2002, what is the difference between the Value added (current US$) of Costa Rica and Value added (current US$) of Djibouti?
Give a very brief answer. 3.26e+09. In the year 2002, what is the difference between the Value added (current US$) in Costa Rica and Value added (current US$) in Hungary?
Provide a succinct answer. -9.26e+09. In the year 2002, what is the difference between the Value added (current US$) in Costa Rica and Value added (current US$) in Indonesia?
Provide a succinct answer. -5.29e+1. In the year 2002, what is the difference between the Value added (current US$) of Djibouti and Value added (current US$) of Hungary?
Provide a short and direct response. -1.25e+1. In the year 2002, what is the difference between the Value added (current US$) of Djibouti and Value added (current US$) of Indonesia?
Provide a short and direct response. -5.62e+1. In the year 2002, what is the difference between the Value added (current US$) of Hungary and Value added (current US$) of Indonesia?
Offer a very short reply. -4.37e+1. In the year 2003, what is the difference between the Value added (current US$) in Costa Rica and Value added (current US$) in Djibouti?
Make the answer very short. 3.35e+09. In the year 2003, what is the difference between the Value added (current US$) of Costa Rica and Value added (current US$) of Hungary?
Your answer should be very brief. -1.24e+1. In the year 2003, what is the difference between the Value added (current US$) of Costa Rica and Value added (current US$) of Indonesia?
Provide a short and direct response. -6.30e+1. In the year 2003, what is the difference between the Value added (current US$) of Djibouti and Value added (current US$) of Hungary?
Your response must be concise. -1.57e+1. In the year 2003, what is the difference between the Value added (current US$) in Djibouti and Value added (current US$) in Indonesia?
Give a very brief answer. -6.63e+1. In the year 2003, what is the difference between the Value added (current US$) of Hungary and Value added (current US$) of Indonesia?
Keep it short and to the point. -5.06e+1. In the year 2004, what is the difference between the Value added (current US$) in Costa Rica and Value added (current US$) in Djibouti?
Offer a terse response. 3.65e+09. In the year 2004, what is the difference between the Value added (current US$) of Costa Rica and Value added (current US$) of Hungary?
Provide a succinct answer. -1.58e+1. In the year 2004, what is the difference between the Value added (current US$) in Costa Rica and Value added (current US$) in Indonesia?
Offer a very short reply. -6.84e+1. In the year 2004, what is the difference between the Value added (current US$) of Djibouti and Value added (current US$) of Hungary?
Your response must be concise. -1.95e+1. In the year 2004, what is the difference between the Value added (current US$) of Djibouti and Value added (current US$) of Indonesia?
Keep it short and to the point. -7.21e+1. In the year 2004, what is the difference between the Value added (current US$) in Hungary and Value added (current US$) in Indonesia?
Your response must be concise. -5.26e+1. In the year 2005, what is the difference between the Value added (current US$) in Costa Rica and Value added (current US$) in Djibouti?
Provide a succinct answer. 3.90e+09. In the year 2005, what is the difference between the Value added (current US$) of Costa Rica and Value added (current US$) of Hungary?
Provide a short and direct response. -1.74e+1. In the year 2005, what is the difference between the Value added (current US$) in Costa Rica and Value added (current US$) in Indonesia?
Give a very brief answer. -7.44e+1. In the year 2005, what is the difference between the Value added (current US$) in Djibouti and Value added (current US$) in Hungary?
Your response must be concise. -2.13e+1. In the year 2005, what is the difference between the Value added (current US$) in Djibouti and Value added (current US$) in Indonesia?
Provide a short and direct response. -7.83e+1. In the year 2005, what is the difference between the Value added (current US$) in Hungary and Value added (current US$) in Indonesia?
Offer a very short reply. -5.70e+1. In the year 2006, what is the difference between the Value added (current US$) in Costa Rica and Value added (current US$) in Djibouti?
Make the answer very short. 4.38e+09. In the year 2006, what is the difference between the Value added (current US$) in Costa Rica and Value added (current US$) in Hungary?
Your answer should be compact. -1.82e+1. In the year 2006, what is the difference between the Value added (current US$) in Costa Rica and Value added (current US$) in Indonesia?
Your answer should be compact. -9.60e+1. In the year 2006, what is the difference between the Value added (current US$) of Djibouti and Value added (current US$) of Hungary?
Give a very brief answer. -2.26e+1. In the year 2006, what is the difference between the Value added (current US$) of Djibouti and Value added (current US$) of Indonesia?
Give a very brief answer. -1.00e+11. In the year 2006, what is the difference between the Value added (current US$) of Hungary and Value added (current US$) of Indonesia?
Keep it short and to the point. -7.78e+1. In the year 2007, what is the difference between the Value added (current US$) of Costa Rica and Value added (current US$) of Djibouti?
Your answer should be compact. 5.01e+09. In the year 2007, what is the difference between the Value added (current US$) of Costa Rica and Value added (current US$) of Hungary?
Offer a very short reply. -2.16e+1. In the year 2007, what is the difference between the Value added (current US$) of Costa Rica and Value added (current US$) of Indonesia?
Your answer should be very brief. -1.12e+11. In the year 2007, what is the difference between the Value added (current US$) of Djibouti and Value added (current US$) of Hungary?
Provide a succinct answer. -2.66e+1. In the year 2007, what is the difference between the Value added (current US$) in Djibouti and Value added (current US$) in Indonesia?
Offer a terse response. -1.17e+11. In the year 2007, what is the difference between the Value added (current US$) in Hungary and Value added (current US$) in Indonesia?
Your answer should be compact. -9.03e+1. What is the ratio of the Value added (current US$) of Costa Rica in 2000 to that in 2001?
Provide a succinct answer. 1.13. What is the ratio of the Value added (current US$) of Djibouti in 2000 to that in 2001?
Ensure brevity in your answer.  0.95. What is the ratio of the Value added (current US$) of Hungary in 2000 to that in 2001?
Provide a short and direct response. 0.88. What is the ratio of the Value added (current US$) of Indonesia in 2000 to that in 2001?
Give a very brief answer. 0.98. What is the ratio of the Value added (current US$) of Costa Rica in 2000 to that in 2002?
Your response must be concise. 1.12. What is the ratio of the Value added (current US$) in Djibouti in 2000 to that in 2002?
Your answer should be compact. 0.92. What is the ratio of the Value added (current US$) of Hungary in 2000 to that in 2002?
Your response must be concise. 0.72. What is the ratio of the Value added (current US$) of Indonesia in 2000 to that in 2002?
Offer a terse response. 0.81. What is the ratio of the Value added (current US$) of Costa Rica in 2000 to that in 2003?
Make the answer very short. 1.09. What is the ratio of the Value added (current US$) of Djibouti in 2000 to that in 2003?
Your response must be concise. 0.87. What is the ratio of the Value added (current US$) in Hungary in 2000 to that in 2003?
Your answer should be compact. 0.57. What is the ratio of the Value added (current US$) of Indonesia in 2000 to that in 2003?
Provide a succinct answer. 0.69. What is the ratio of the Value added (current US$) of Costa Rica in 2000 to that in 2004?
Ensure brevity in your answer.  1. What is the ratio of the Value added (current US$) in Djibouti in 2000 to that in 2004?
Your answer should be compact. 0.81. What is the ratio of the Value added (current US$) in Hungary in 2000 to that in 2004?
Offer a terse response. 0.46. What is the ratio of the Value added (current US$) in Indonesia in 2000 to that in 2004?
Offer a terse response. 0.64. What is the ratio of the Value added (current US$) in Costa Rica in 2000 to that in 2005?
Give a very brief answer. 0.94. What is the ratio of the Value added (current US$) in Djibouti in 2000 to that in 2005?
Give a very brief answer. 0.77. What is the ratio of the Value added (current US$) in Hungary in 2000 to that in 2005?
Make the answer very short. 0.42. What is the ratio of the Value added (current US$) in Indonesia in 2000 to that in 2005?
Offer a very short reply. 0.58. What is the ratio of the Value added (current US$) of Costa Rica in 2000 to that in 2006?
Offer a terse response. 0.84. What is the ratio of the Value added (current US$) in Djibouti in 2000 to that in 2006?
Ensure brevity in your answer.  0.73. What is the ratio of the Value added (current US$) of Hungary in 2000 to that in 2006?
Make the answer very short. 0.4. What is the ratio of the Value added (current US$) of Indonesia in 2000 to that in 2006?
Provide a short and direct response. 0.46. What is the ratio of the Value added (current US$) in Costa Rica in 2000 to that in 2007?
Keep it short and to the point. 0.73. What is the ratio of the Value added (current US$) in Djibouti in 2000 to that in 2007?
Provide a short and direct response. 0.69. What is the ratio of the Value added (current US$) in Hungary in 2000 to that in 2007?
Provide a succinct answer. 0.34. What is the ratio of the Value added (current US$) of Indonesia in 2000 to that in 2007?
Keep it short and to the point. 0.39. What is the ratio of the Value added (current US$) of Djibouti in 2001 to that in 2002?
Keep it short and to the point. 0.96. What is the ratio of the Value added (current US$) in Hungary in 2001 to that in 2002?
Make the answer very short. 0.82. What is the ratio of the Value added (current US$) in Indonesia in 2001 to that in 2002?
Keep it short and to the point. 0.83. What is the ratio of the Value added (current US$) in Costa Rica in 2001 to that in 2003?
Your response must be concise. 0.96. What is the ratio of the Value added (current US$) in Djibouti in 2001 to that in 2003?
Your answer should be very brief. 0.92. What is the ratio of the Value added (current US$) of Hungary in 2001 to that in 2003?
Give a very brief answer. 0.65. What is the ratio of the Value added (current US$) of Indonesia in 2001 to that in 2003?
Ensure brevity in your answer.  0.7. What is the ratio of the Value added (current US$) in Costa Rica in 2001 to that in 2004?
Give a very brief answer. 0.89. What is the ratio of the Value added (current US$) in Djibouti in 2001 to that in 2004?
Offer a terse response. 0.85. What is the ratio of the Value added (current US$) of Hungary in 2001 to that in 2004?
Your answer should be compact. 0.53. What is the ratio of the Value added (current US$) of Indonesia in 2001 to that in 2004?
Ensure brevity in your answer.  0.65. What is the ratio of the Value added (current US$) of Costa Rica in 2001 to that in 2005?
Offer a terse response. 0.83. What is the ratio of the Value added (current US$) in Djibouti in 2001 to that in 2005?
Ensure brevity in your answer.  0.81. What is the ratio of the Value added (current US$) in Hungary in 2001 to that in 2005?
Offer a terse response. 0.48. What is the ratio of the Value added (current US$) of Indonesia in 2001 to that in 2005?
Your answer should be very brief. 0.59. What is the ratio of the Value added (current US$) of Costa Rica in 2001 to that in 2006?
Provide a succinct answer. 0.74. What is the ratio of the Value added (current US$) of Djibouti in 2001 to that in 2006?
Offer a very short reply. 0.76. What is the ratio of the Value added (current US$) in Hungary in 2001 to that in 2006?
Provide a short and direct response. 0.46. What is the ratio of the Value added (current US$) of Indonesia in 2001 to that in 2006?
Your response must be concise. 0.46. What is the ratio of the Value added (current US$) in Costa Rica in 2001 to that in 2007?
Offer a terse response. 0.65. What is the ratio of the Value added (current US$) of Djibouti in 2001 to that in 2007?
Your response must be concise. 0.72. What is the ratio of the Value added (current US$) of Hungary in 2001 to that in 2007?
Your answer should be very brief. 0.39. What is the ratio of the Value added (current US$) in Indonesia in 2001 to that in 2007?
Give a very brief answer. 0.4. What is the ratio of the Value added (current US$) of Costa Rica in 2002 to that in 2003?
Offer a terse response. 0.97. What is the ratio of the Value added (current US$) in Djibouti in 2002 to that in 2003?
Your response must be concise. 0.95. What is the ratio of the Value added (current US$) of Hungary in 2002 to that in 2003?
Provide a short and direct response. 0.8. What is the ratio of the Value added (current US$) of Indonesia in 2002 to that in 2003?
Make the answer very short. 0.85. What is the ratio of the Value added (current US$) in Costa Rica in 2002 to that in 2004?
Make the answer very short. 0.9. What is the ratio of the Value added (current US$) of Djibouti in 2002 to that in 2004?
Your answer should be compact. 0.89. What is the ratio of the Value added (current US$) of Hungary in 2002 to that in 2004?
Your answer should be very brief. 0.64. What is the ratio of the Value added (current US$) in Indonesia in 2002 to that in 2004?
Make the answer very short. 0.78. What is the ratio of the Value added (current US$) of Costa Rica in 2002 to that in 2005?
Your response must be concise. 0.84. What is the ratio of the Value added (current US$) in Djibouti in 2002 to that in 2005?
Provide a succinct answer. 0.84. What is the ratio of the Value added (current US$) in Hungary in 2002 to that in 2005?
Provide a short and direct response. 0.59. What is the ratio of the Value added (current US$) in Indonesia in 2002 to that in 2005?
Your answer should be compact. 0.72. What is the ratio of the Value added (current US$) in Costa Rica in 2002 to that in 2006?
Ensure brevity in your answer.  0.75. What is the ratio of the Value added (current US$) of Djibouti in 2002 to that in 2006?
Ensure brevity in your answer.  0.79. What is the ratio of the Value added (current US$) of Hungary in 2002 to that in 2006?
Ensure brevity in your answer.  0.55. What is the ratio of the Value added (current US$) in Indonesia in 2002 to that in 2006?
Ensure brevity in your answer.  0.56. What is the ratio of the Value added (current US$) in Costa Rica in 2002 to that in 2007?
Provide a short and direct response. 0.65. What is the ratio of the Value added (current US$) of Djibouti in 2002 to that in 2007?
Ensure brevity in your answer.  0.75. What is the ratio of the Value added (current US$) of Hungary in 2002 to that in 2007?
Your response must be concise. 0.47. What is the ratio of the Value added (current US$) in Indonesia in 2002 to that in 2007?
Provide a succinct answer. 0.48. What is the ratio of the Value added (current US$) in Costa Rica in 2003 to that in 2004?
Your response must be concise. 0.92. What is the ratio of the Value added (current US$) in Djibouti in 2003 to that in 2004?
Offer a terse response. 0.93. What is the ratio of the Value added (current US$) in Hungary in 2003 to that in 2004?
Your answer should be compact. 0.81. What is the ratio of the Value added (current US$) of Indonesia in 2003 to that in 2004?
Provide a succinct answer. 0.92. What is the ratio of the Value added (current US$) in Costa Rica in 2003 to that in 2005?
Your response must be concise. 0.86. What is the ratio of the Value added (current US$) in Djibouti in 2003 to that in 2005?
Make the answer very short. 0.88. What is the ratio of the Value added (current US$) in Hungary in 2003 to that in 2005?
Keep it short and to the point. 0.74. What is the ratio of the Value added (current US$) in Indonesia in 2003 to that in 2005?
Make the answer very short. 0.85. What is the ratio of the Value added (current US$) of Costa Rica in 2003 to that in 2006?
Make the answer very short. 0.76. What is the ratio of the Value added (current US$) of Djibouti in 2003 to that in 2006?
Keep it short and to the point. 0.83. What is the ratio of the Value added (current US$) in Hungary in 2003 to that in 2006?
Your answer should be very brief. 0.7. What is the ratio of the Value added (current US$) of Indonesia in 2003 to that in 2006?
Make the answer very short. 0.66. What is the ratio of the Value added (current US$) in Costa Rica in 2003 to that in 2007?
Your answer should be compact. 0.67. What is the ratio of the Value added (current US$) in Djibouti in 2003 to that in 2007?
Provide a succinct answer. 0.79. What is the ratio of the Value added (current US$) of Hungary in 2003 to that in 2007?
Your response must be concise. 0.59. What is the ratio of the Value added (current US$) in Indonesia in 2003 to that in 2007?
Your answer should be very brief. 0.57. What is the ratio of the Value added (current US$) of Costa Rica in 2004 to that in 2005?
Keep it short and to the point. 0.94. What is the ratio of the Value added (current US$) of Djibouti in 2004 to that in 2005?
Offer a terse response. 0.95. What is the ratio of the Value added (current US$) in Hungary in 2004 to that in 2005?
Your answer should be very brief. 0.91. What is the ratio of the Value added (current US$) of Indonesia in 2004 to that in 2005?
Provide a succinct answer. 0.92. What is the ratio of the Value added (current US$) of Costa Rica in 2004 to that in 2006?
Give a very brief answer. 0.83. What is the ratio of the Value added (current US$) of Djibouti in 2004 to that in 2006?
Offer a terse response. 0.89. What is the ratio of the Value added (current US$) in Hungary in 2004 to that in 2006?
Your answer should be very brief. 0.86. What is the ratio of the Value added (current US$) of Indonesia in 2004 to that in 2006?
Make the answer very short. 0.72. What is the ratio of the Value added (current US$) in Costa Rica in 2004 to that in 2007?
Make the answer very short. 0.73. What is the ratio of the Value added (current US$) of Djibouti in 2004 to that in 2007?
Your response must be concise. 0.84. What is the ratio of the Value added (current US$) in Hungary in 2004 to that in 2007?
Make the answer very short. 0.73. What is the ratio of the Value added (current US$) of Indonesia in 2004 to that in 2007?
Give a very brief answer. 0.62. What is the ratio of the Value added (current US$) of Costa Rica in 2005 to that in 2006?
Offer a terse response. 0.89. What is the ratio of the Value added (current US$) in Djibouti in 2005 to that in 2006?
Make the answer very short. 0.94. What is the ratio of the Value added (current US$) in Hungary in 2005 to that in 2006?
Your answer should be very brief. 0.94. What is the ratio of the Value added (current US$) in Indonesia in 2005 to that in 2006?
Provide a succinct answer. 0.78. What is the ratio of the Value added (current US$) in Costa Rica in 2005 to that in 2007?
Offer a very short reply. 0.78. What is the ratio of the Value added (current US$) of Djibouti in 2005 to that in 2007?
Your response must be concise. 0.89. What is the ratio of the Value added (current US$) in Hungary in 2005 to that in 2007?
Make the answer very short. 0.8. What is the ratio of the Value added (current US$) of Indonesia in 2005 to that in 2007?
Ensure brevity in your answer.  0.67. What is the ratio of the Value added (current US$) in Costa Rica in 2006 to that in 2007?
Offer a terse response. 0.87. What is the ratio of the Value added (current US$) of Djibouti in 2006 to that in 2007?
Provide a succinct answer. 0.94. What is the ratio of the Value added (current US$) of Hungary in 2006 to that in 2007?
Offer a terse response. 0.85. What is the ratio of the Value added (current US$) of Indonesia in 2006 to that in 2007?
Your answer should be very brief. 0.86. What is the difference between the highest and the second highest Value added (current US$) of Costa Rica?
Give a very brief answer. 6.32e+08. What is the difference between the highest and the second highest Value added (current US$) of Djibouti?
Provide a succinct answer. 1.05e+06. What is the difference between the highest and the second highest Value added (current US$) in Hungary?
Give a very brief answer. 3.99e+09. What is the difference between the highest and the second highest Value added (current US$) in Indonesia?
Offer a terse response. 1.65e+1. What is the difference between the highest and the lowest Value added (current US$) in Costa Rica?
Give a very brief answer. 1.78e+09. What is the difference between the highest and the lowest Value added (current US$) of Djibouti?
Your answer should be very brief. 5.74e+06. What is the difference between the highest and the lowest Value added (current US$) in Hungary?
Your answer should be compact. 1.76e+1. What is the difference between the highest and the lowest Value added (current US$) in Indonesia?
Your answer should be compact. 7.11e+1. 